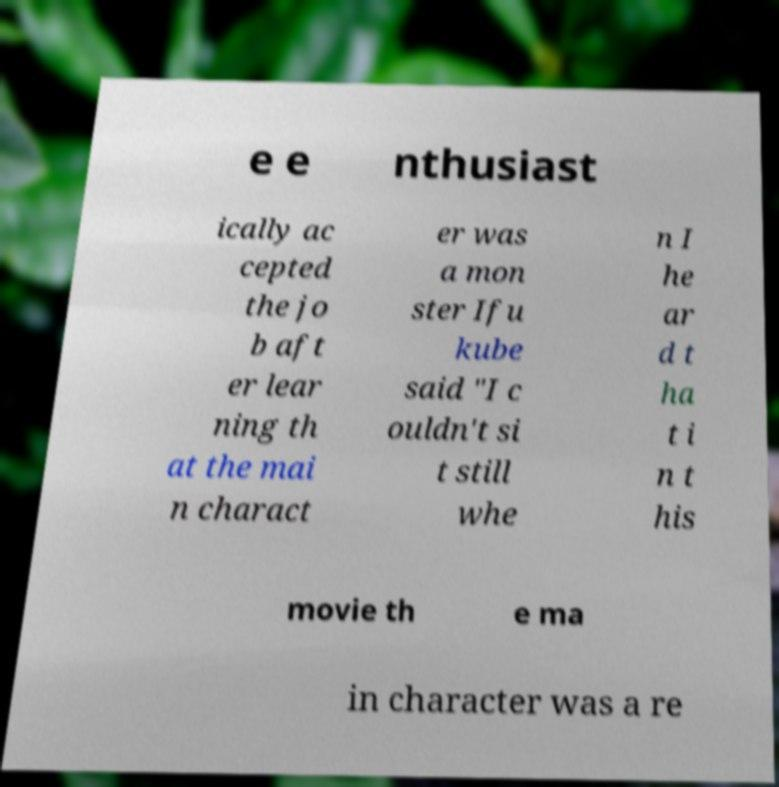Please identify and transcribe the text found in this image. e e nthusiast ically ac cepted the jo b aft er lear ning th at the mai n charact er was a mon ster Ifu kube said "I c ouldn't si t still whe n I he ar d t ha t i n t his movie th e ma in character was a re 